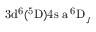<formula> <loc_0><loc_0><loc_500><loc_500>3 d ^ { 6 } ( ^ { 5 } D ) 4 s \ a \, ^ { 6 } D _ { J }</formula> 